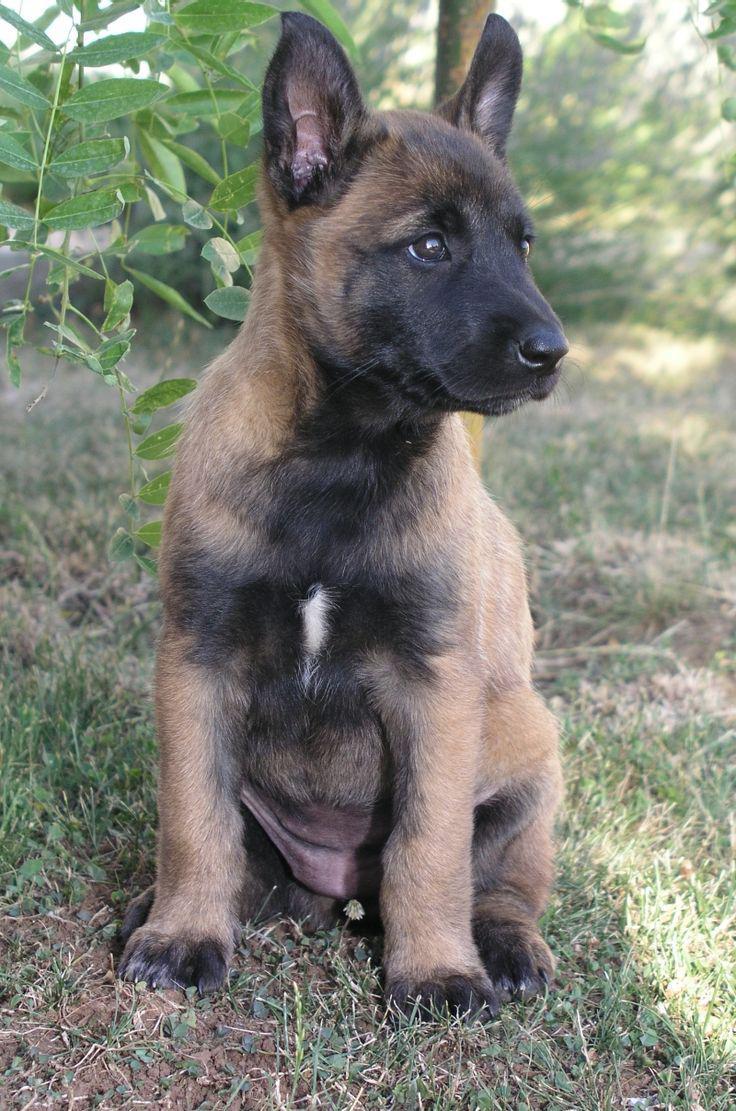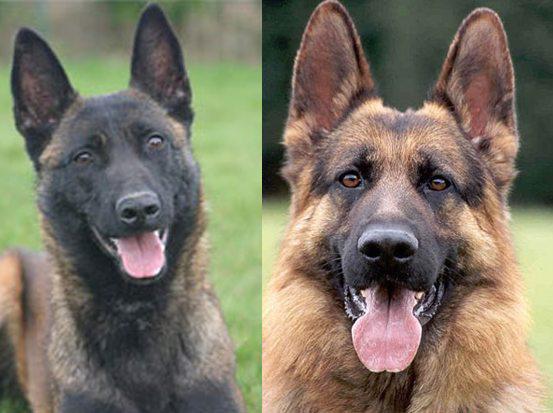The first image is the image on the left, the second image is the image on the right. Analyze the images presented: Is the assertion "At least one dog has its tongue out." valid? Answer yes or no. Yes. The first image is the image on the left, the second image is the image on the right. For the images displayed, is the sentence "Left image features a german shepherd sitting upright outdoors." factually correct? Answer yes or no. Yes. 